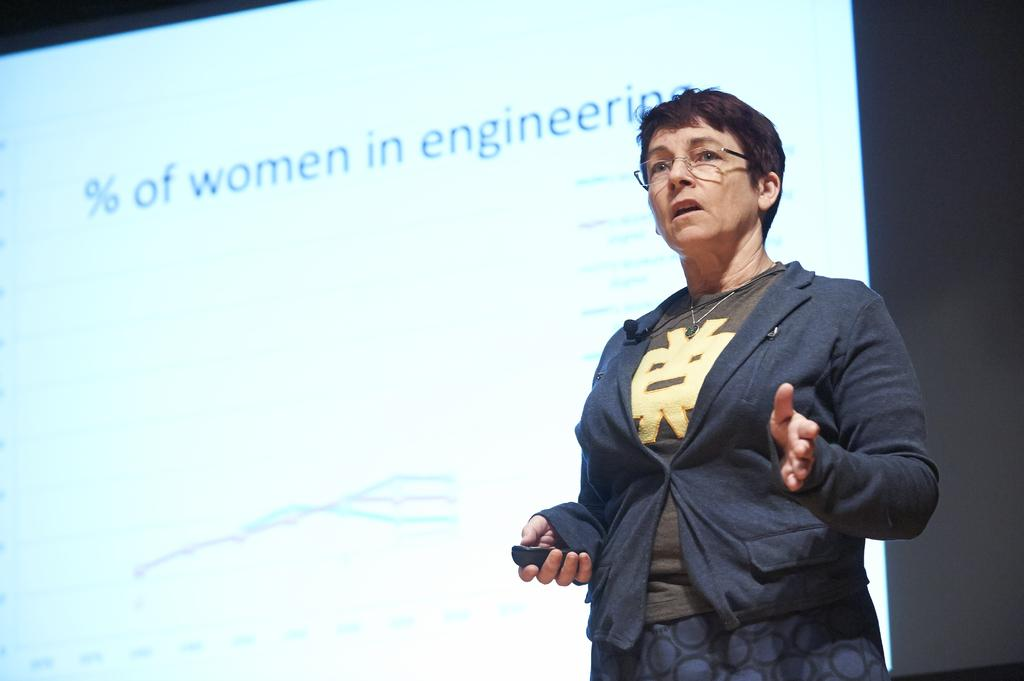What is the woman doing in the image? The woman is standing in the image. What is the woman holding in the image? The woman is holding an object. On which side of the image is the woman located? The woman is on the right side of the image. What can be seen on the wall in the background of the image? There is a screen on the wall in the background of the image. What type of pancake is being served on the island in the image? There is no pancake or island present in the image. What tax-related information can be seen on the screen in the background? The screen on the wall in the background does not display any tax-related information; it is not mentioned in the provided facts. 